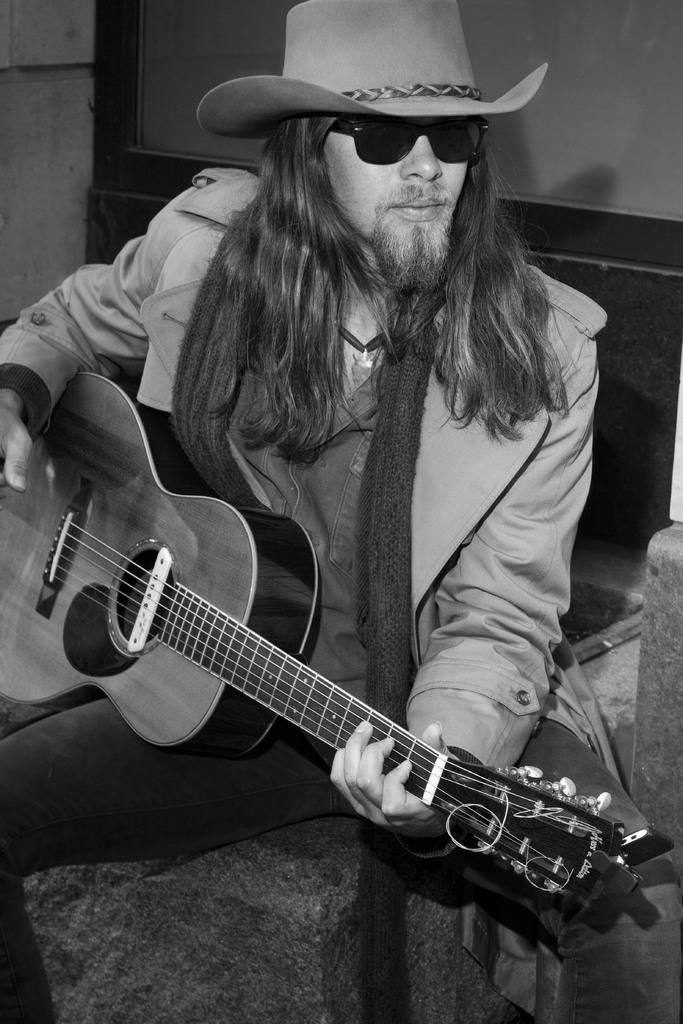What is the main subject of the image? There is a man in the image. What is the man doing in the image? The man is sitting in the image. What object is the man holding in the image? The man is holding a guitar in the image. What accessories is the man wearing in the image? The man is wearing a cap and shades in the image. How many lizards can be seen crawling on the guitar in the image? There are no lizards present in the image, and therefore no such activity can be observed. 